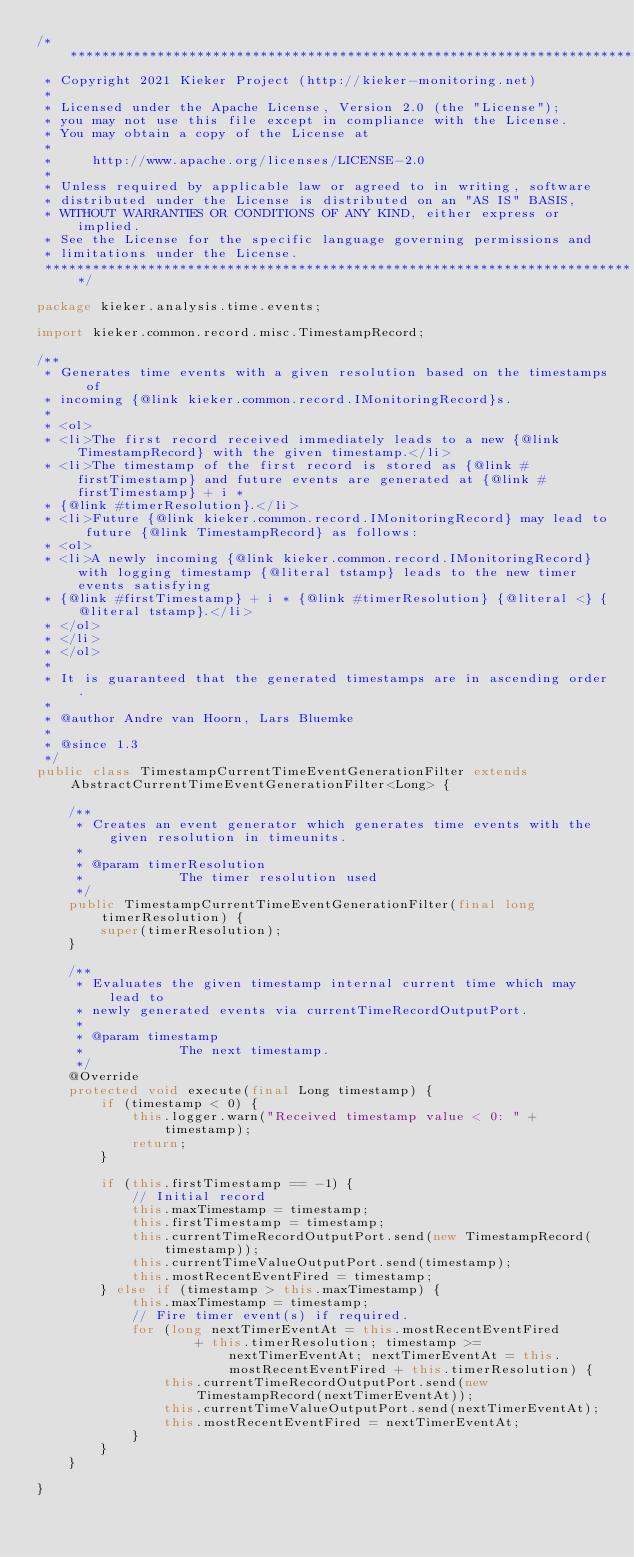Convert code to text. <code><loc_0><loc_0><loc_500><loc_500><_Java_>/***************************************************************************
 * Copyright 2021 Kieker Project (http://kieker-monitoring.net)
 *
 * Licensed under the Apache License, Version 2.0 (the "License");
 * you may not use this file except in compliance with the License.
 * You may obtain a copy of the License at
 *
 *     http://www.apache.org/licenses/LICENSE-2.0
 *
 * Unless required by applicable law or agreed to in writing, software
 * distributed under the License is distributed on an "AS IS" BASIS,
 * WITHOUT WARRANTIES OR CONDITIONS OF ANY KIND, either express or implied.
 * See the License for the specific language governing permissions and
 * limitations under the License.
 ***************************************************************************/

package kieker.analysis.time.events;

import kieker.common.record.misc.TimestampRecord;

/**
 * Generates time events with a given resolution based on the timestamps of
 * incoming {@link kieker.common.record.IMonitoringRecord}s.
 *
 * <ol>
 * <li>The first record received immediately leads to a new {@link TimestampRecord} with the given timestamp.</li>
 * <li>The timestamp of the first record is stored as {@link #firstTimestamp} and future events are generated at {@link #firstTimestamp} + i *
 * {@link #timerResolution}.</li>
 * <li>Future {@link kieker.common.record.IMonitoringRecord} may lead to future {@link TimestampRecord} as follows:
 * <ol>
 * <li>A newly incoming {@link kieker.common.record.IMonitoringRecord} with logging timestamp {@literal tstamp} leads to the new timer events satisfying
 * {@link #firstTimestamp} + i * {@link #timerResolution} {@literal <} {@literal tstamp}.</li>
 * </ol>
 * </li>
 * </ol>
 *
 * It is guaranteed that the generated timestamps are in ascending order.
 *
 * @author Andre van Hoorn, Lars Bluemke
 *
 * @since 1.3
 */
public class TimestampCurrentTimeEventGenerationFilter extends AbstractCurrentTimeEventGenerationFilter<Long> {

	/**
	 * Creates an event generator which generates time events with the given resolution in timeunits.
	 *
	 * @param timerResolution
	 *            The timer resolution used
	 */
	public TimestampCurrentTimeEventGenerationFilter(final long timerResolution) {
		super(timerResolution);
	}

	/**
	 * Evaluates the given timestamp internal current time which may lead to
	 * newly generated events via currentTimeRecordOutputPort.
	 *
	 * @param timestamp
	 *            The next timestamp.
	 */
	@Override
	protected void execute(final Long timestamp) {
		if (timestamp < 0) {
			this.logger.warn("Received timestamp value < 0: " + timestamp);
			return;
		}

		if (this.firstTimestamp == -1) {
			// Initial record
			this.maxTimestamp = timestamp;
			this.firstTimestamp = timestamp;
			this.currentTimeRecordOutputPort.send(new TimestampRecord(timestamp));
			this.currentTimeValueOutputPort.send(timestamp);
			this.mostRecentEventFired = timestamp;
		} else if (timestamp > this.maxTimestamp) {
			this.maxTimestamp = timestamp;
			// Fire timer event(s) if required.
			for (long nextTimerEventAt = this.mostRecentEventFired
					+ this.timerResolution; timestamp >= nextTimerEventAt; nextTimerEventAt = this.mostRecentEventFired + this.timerResolution) {
				this.currentTimeRecordOutputPort.send(new TimestampRecord(nextTimerEventAt));
				this.currentTimeValueOutputPort.send(nextTimerEventAt);
				this.mostRecentEventFired = nextTimerEventAt;
			}
		}
	}

}
</code> 